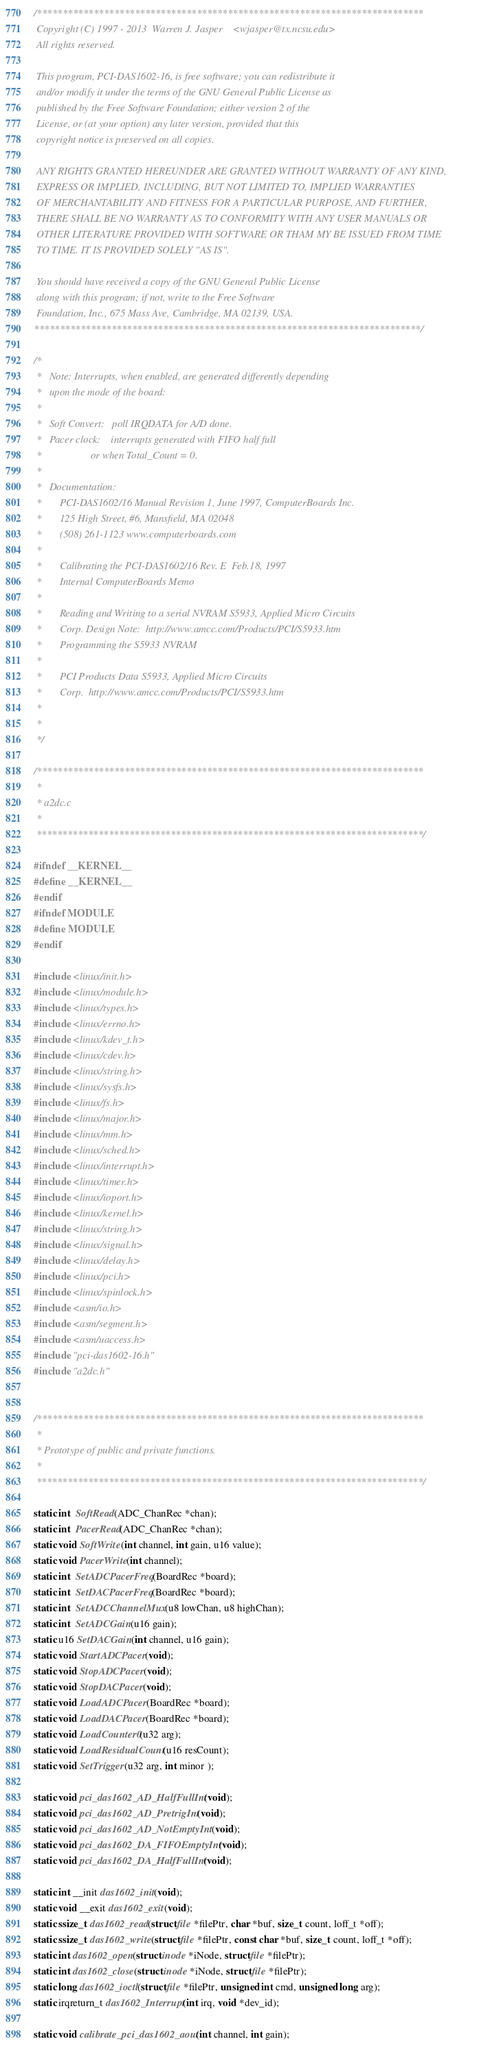<code> <loc_0><loc_0><loc_500><loc_500><_C_>/***************************************************************************
 Copyright (C) 1997 - 2013  Warren J. Jasper    <wjasper@tx.ncsu.edu>
 All rights reserved.

 This program, PCI-DAS1602-16, is free software; you can redistribute it
 and/or modify it under the terms of the GNU General Public License as
 published by the Free Software Foundation; either version 2 of the
 License, or (at your option) any later version, provided that this
 copyright notice is preserved on all copies.

 ANY RIGHTS GRANTED HEREUNDER ARE GRANTED WITHOUT WARRANTY OF ANY KIND,
 EXPRESS OR IMPLIED, INCLUDING, BUT NOT LIMITED TO, IMPLIED WARRANTIES
 OF MERCHANTABILITY AND FITNESS FOR A PARTICULAR PURPOSE, AND FURTHER,
 THERE SHALL BE NO WARRANTY AS TO CONFORMITY WITH ANY USER MANUALS OR
 OTHER LITERATURE PROVIDED WITH SOFTWARE OR THAM MY BE ISSUED FROM TIME
 TO TIME. IT IS PROVIDED SOLELY "AS IS".

 You should have received a copy of the GNU General Public License
 along with this program; if not, write to the Free Software
 Foundation, Inc., 675 Mass Ave, Cambridge, MA 02139, USA.
***************************************************************************/

/*
 *   Note: Interrupts, when enabled, are generated differently depending
 *   upon the mode of the board:
 *
 *   Soft Convert:   poll IRQDATA for A/D done.
 *   Pacer clock:    interrupts generated with FIFO half full
 *                   or when Total_Count = 0.
 *
 *   Documentation:
 *       PCI-DAS1602/16 Manual Revision 1, June 1997, ComputerBoards Inc.
 *       125 High Street, #6, Mansfield, MA 02048
 *       (508) 261-1123 www.computerboards.com
 *
 *       Calibrating the PCI-DAS1602/16 Rev. E  Feb.18, 1997
 *       Internal ComputerBoards Memo
 *
 *       Reading and Writing to a serial NVRAM S5933, Applied Micro Circuits
 *       Corp. Design Note:  http://www.amcc.com/Products/PCI/S5933.htm
 *       Programming the S5933 NVRAM
 *
 *       PCI Products Data S5933, Applied Micro Circuits
 *       Corp.  http://www.amcc.com/Products/PCI/S5933.htm
 *
 *       
 */

/***************************************************************************
 *
 * a2dc.c
 *
 ***************************************************************************/

#ifndef __KERNEL__
#define __KERNEL__
#endif
#ifndef MODULE
#define MODULE
#endif

#include <linux/init.h>
#include <linux/module.h>
#include <linux/types.h>
#include <linux/errno.h>
#include <linux/kdev_t.h>
#include <linux/cdev.h>
#include <linux/string.h>
#include <linux/sysfs.h>
#include <linux/fs.h>
#include <linux/major.h>
#include <linux/mm.h>
#include <linux/sched.h>
#include <linux/interrupt.h>
#include <linux/timer.h>
#include <linux/ioport.h>
#include <linux/kernel.h>
#include <linux/string.h>
#include <linux/signal.h>
#include <linux/delay.h>
#include <linux/pci.h>
#include <linux/spinlock.h>
#include <asm/io.h>
#include <asm/segment.h>
#include <asm/uaccess.h>
#include "pci-das1602-16.h"
#include "a2dc.h"


/***************************************************************************
 *
 * Prototype of public and private functions.
 *
 ***************************************************************************/

static int  SoftRead(ADC_ChanRec *chan);
static int  PacerRead(ADC_ChanRec *chan);
static void SoftWrite(int channel, int gain, u16 value);
static void PacerWrite(int channel);
static int  SetADCPacerFreq(BoardRec *board);
static int  SetDACPacerFreq(BoardRec *board);
static int  SetADCChannelMux(u8 lowChan, u8 highChan);
static int  SetADCGain(u16 gain);
static u16 SetDACGain(int channel, u16 gain);
static void StartADCPacer(void);
static void StopADCPacer(void);
static void StopDACPacer(void);
static void LoadADCPacer(BoardRec *board);
static void LoadDACPacer(BoardRec *board);
static void LoadCounter0(u32 arg);
static void LoadResidualCount(u16 resCount);
static void SetTrigger(u32 arg, int minor );

static void pci_das1602_AD_HalfFullInt(void);
static void pci_das1602_AD_PretrigInt(void);
static void pci_das1602_AD_NotEmptyInt(void);
static void pci_das1602_DA_FIFOEmptyInt(void);
static void pci_das1602_DA_HalfFullInt(void);

static int __init das1602_init(void);
static void __exit das1602_exit(void);
static ssize_t das1602_read(struct file *filePtr, char *buf, size_t count, loff_t *off);
static ssize_t das1602_write(struct file *filePtr, const char *buf, size_t count, loff_t *off);
static int das1602_open(struct inode *iNode, struct file *filePtr);
static int das1602_close(struct inode *iNode, struct file *filePtr);
static long das1602_ioctl(struct file *filePtr, unsigned int cmd, unsigned long arg);
static irqreturn_t das1602_Interrupt(int irq, void *dev_id);

static void calibrate_pci_das1602_aout(int channel, int gain);</code> 